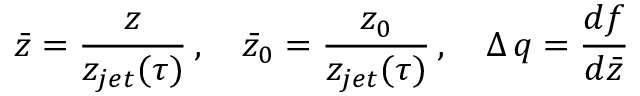Convert formula to latex. <formula><loc_0><loc_0><loc_500><loc_500>\bar { z } = \frac { z } { z _ { j e t } ( \tau ) } \, , \quad \bar { z } _ { 0 } = \frac { z _ { 0 } } { z _ { j e t } ( \tau ) } \, , \quad \Delta \, q = \frac { d f } { d \bar { z } }</formula> 